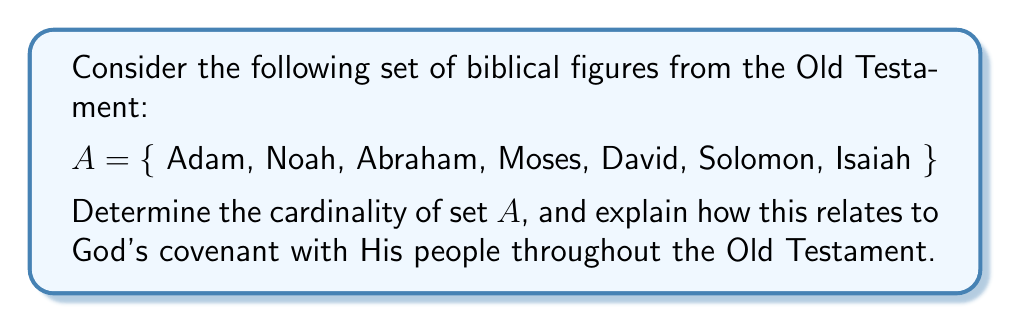Provide a solution to this math problem. To determine the cardinality of set $A$, we need to count the number of distinct elements in the set. Let's break this down step-by-step:

1. Count the elements:
   Adam, Noah, Abraham, Moses, David, Solomon, Isaiah

2. There are 7 distinct names in the set, with no repetitions.

3. Therefore, the cardinality of set $A$ is 7, which we can write as $|A| = 7$.

From a theological perspective, this set of 7 biblical figures represents key individuals in God's covenant relationship with His people throughout the Old Testament:

1. Adam: The first man, representing God's initial covenant with humanity.
2. Noah: God's covenant of preservation after the flood.
3. Abraham: The Abrahamic covenant, promising land, descendants, and blessing.
4. Moses: The Mosaic covenant and the giving of the Law.
5. David: The Davidic covenant, promising an eternal kingdom.
6. Solomon: Represents the wisdom and glory of God's chosen people.
7. Isaiah: Prophesies about the coming Messiah and God's new covenant.

The number 7 itself is significant in biblical numerology, often representing completeness or perfection. This aligns with the completeness of God's plan for salvation history as revealed through these key figures in the Old Testament.
Answer: The cardinality of set $A$ is $|A| = 7$. 